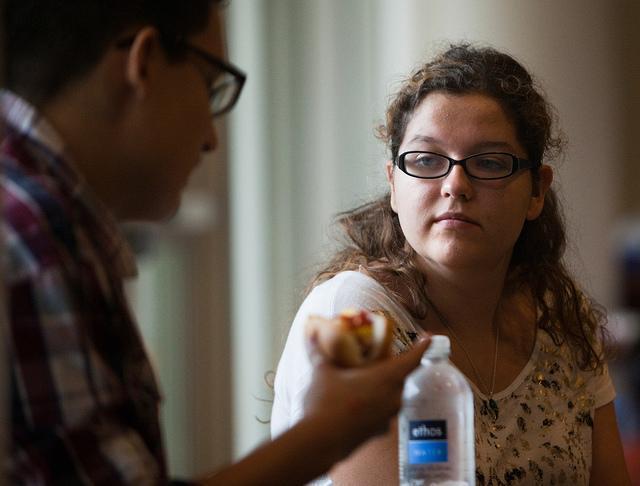How many pairs of glasses?
Give a very brief answer. 2. How many people are visible?
Give a very brief answer. 2. How many bottles are there?
Give a very brief answer. 1. 